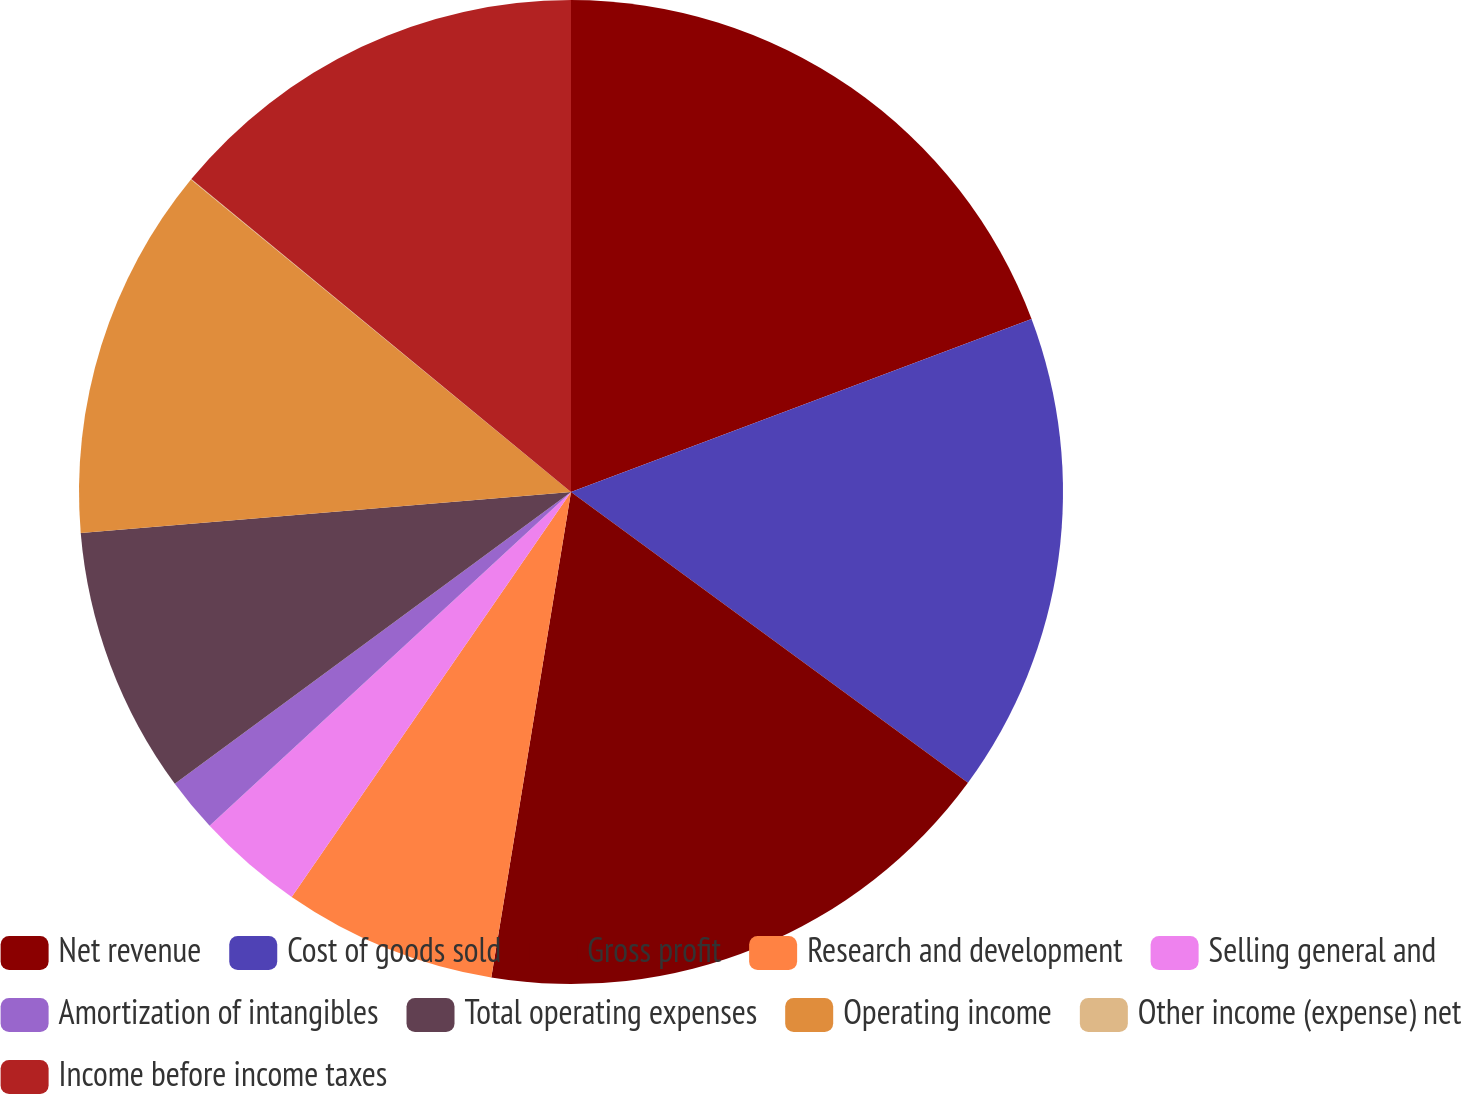<chart> <loc_0><loc_0><loc_500><loc_500><pie_chart><fcel>Net revenue<fcel>Cost of goods sold<fcel>Gross profit<fcel>Research and development<fcel>Selling general and<fcel>Amortization of intangibles<fcel>Total operating expenses<fcel>Operating income<fcel>Other income (expense) net<fcel>Income before income taxes<nl><fcel>19.28%<fcel>15.78%<fcel>17.53%<fcel>7.02%<fcel>3.52%<fcel>1.77%<fcel>8.77%<fcel>12.28%<fcel>0.02%<fcel>14.03%<nl></chart> 